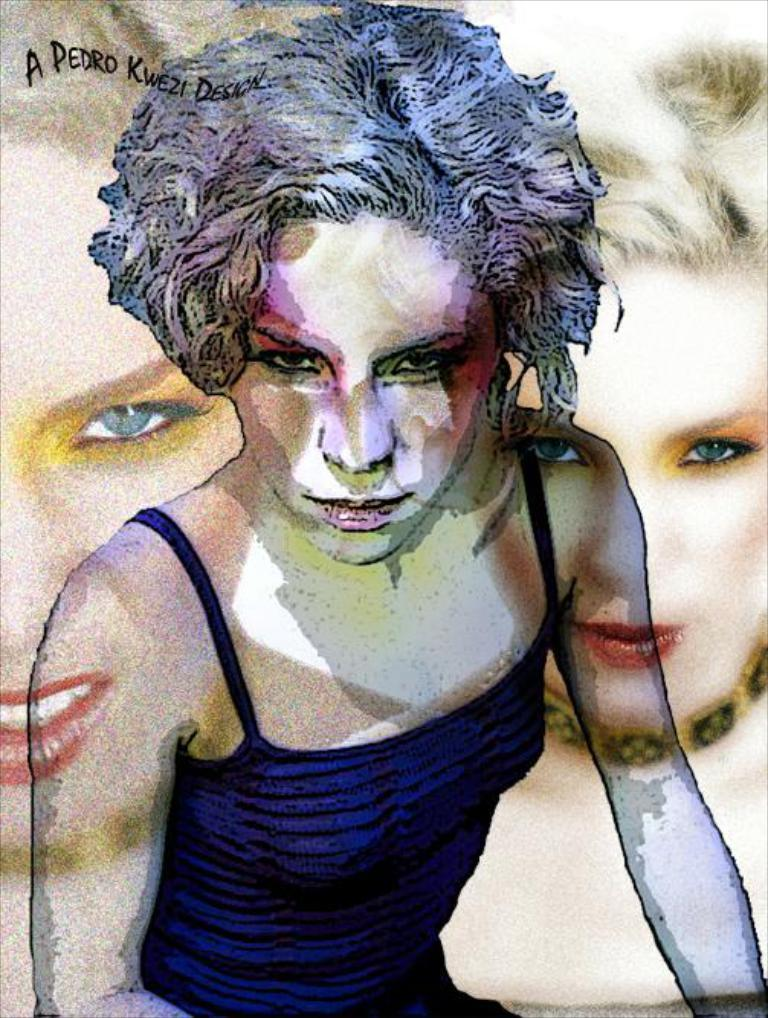What type of image is being described? The image is animated. Can you describe the subjects in the image? There are people in the image. Where is the text located in the image? The text is at the top of the image. What scent can be detected from the image? There is no scent associated with the image, as it is a visual medium. Is there a road visible in the image? There is no mention of a road in the provided facts, so it cannot be determined if one is present in the image. 